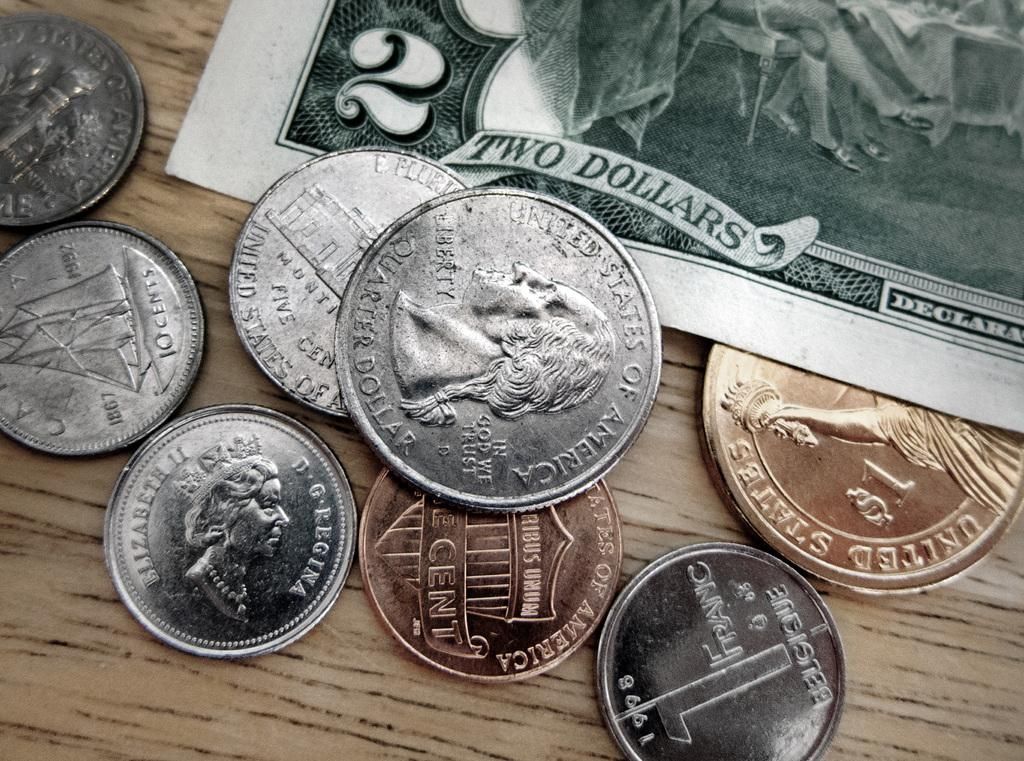What type of money is visible in the image? There are coins and a currency note in the image. On what surface are the coins and currency note placed? The coins and currency note are on a wooden board. How many deer can be seen grazing on the side of the wooden board in the image? There are no deer present in the image; it only features coins and a currency note on a wooden board. 